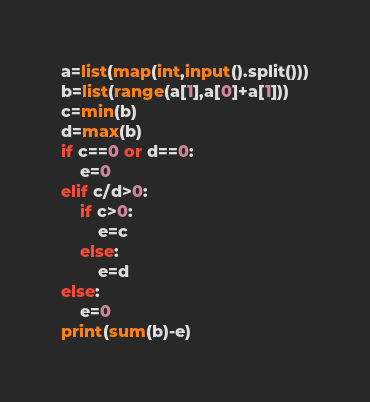<code> <loc_0><loc_0><loc_500><loc_500><_Python_>a=list(map(int,input().split()))
b=list(range(a[1],a[0]+a[1]))
c=min(b)
d=max(b)
if c==0 or d==0:
    e=0
elif c/d>0:
    if c>0:
        e=c
    else:
        e=d
else:
    e=0
print(sum(b)-e)
</code> 